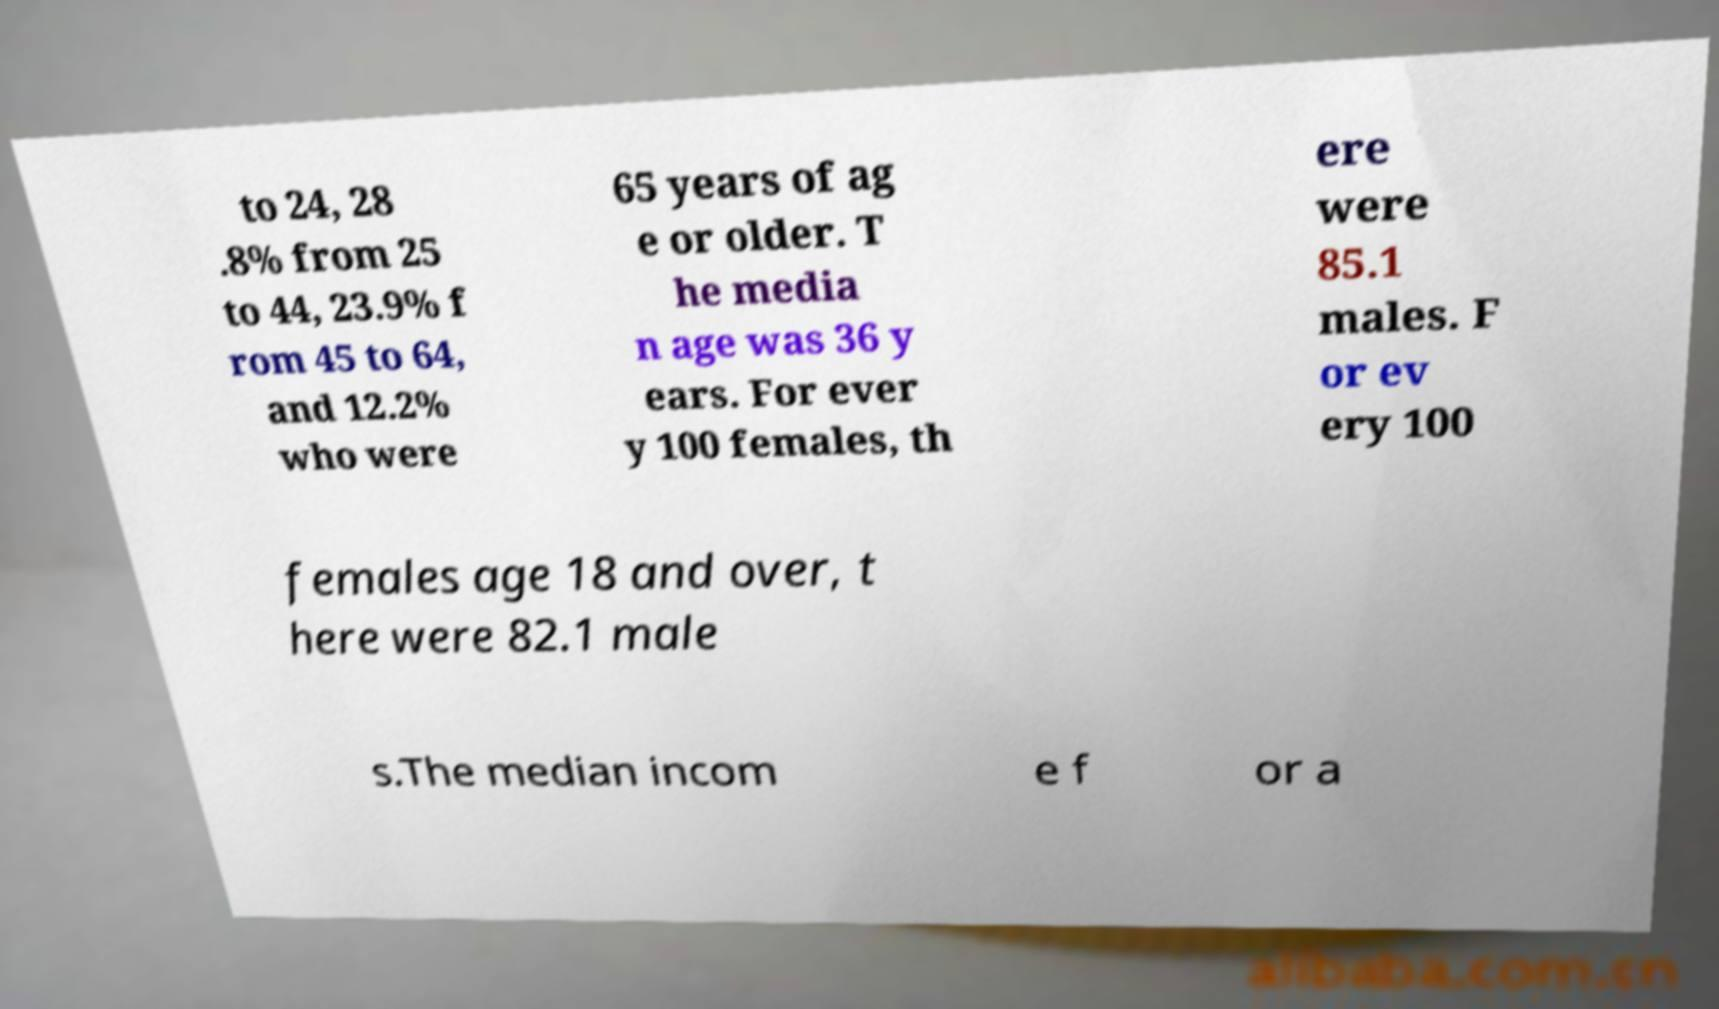What messages or text are displayed in this image? I need them in a readable, typed format. to 24, 28 .8% from 25 to 44, 23.9% f rom 45 to 64, and 12.2% who were 65 years of ag e or older. T he media n age was 36 y ears. For ever y 100 females, th ere were 85.1 males. F or ev ery 100 females age 18 and over, t here were 82.1 male s.The median incom e f or a 